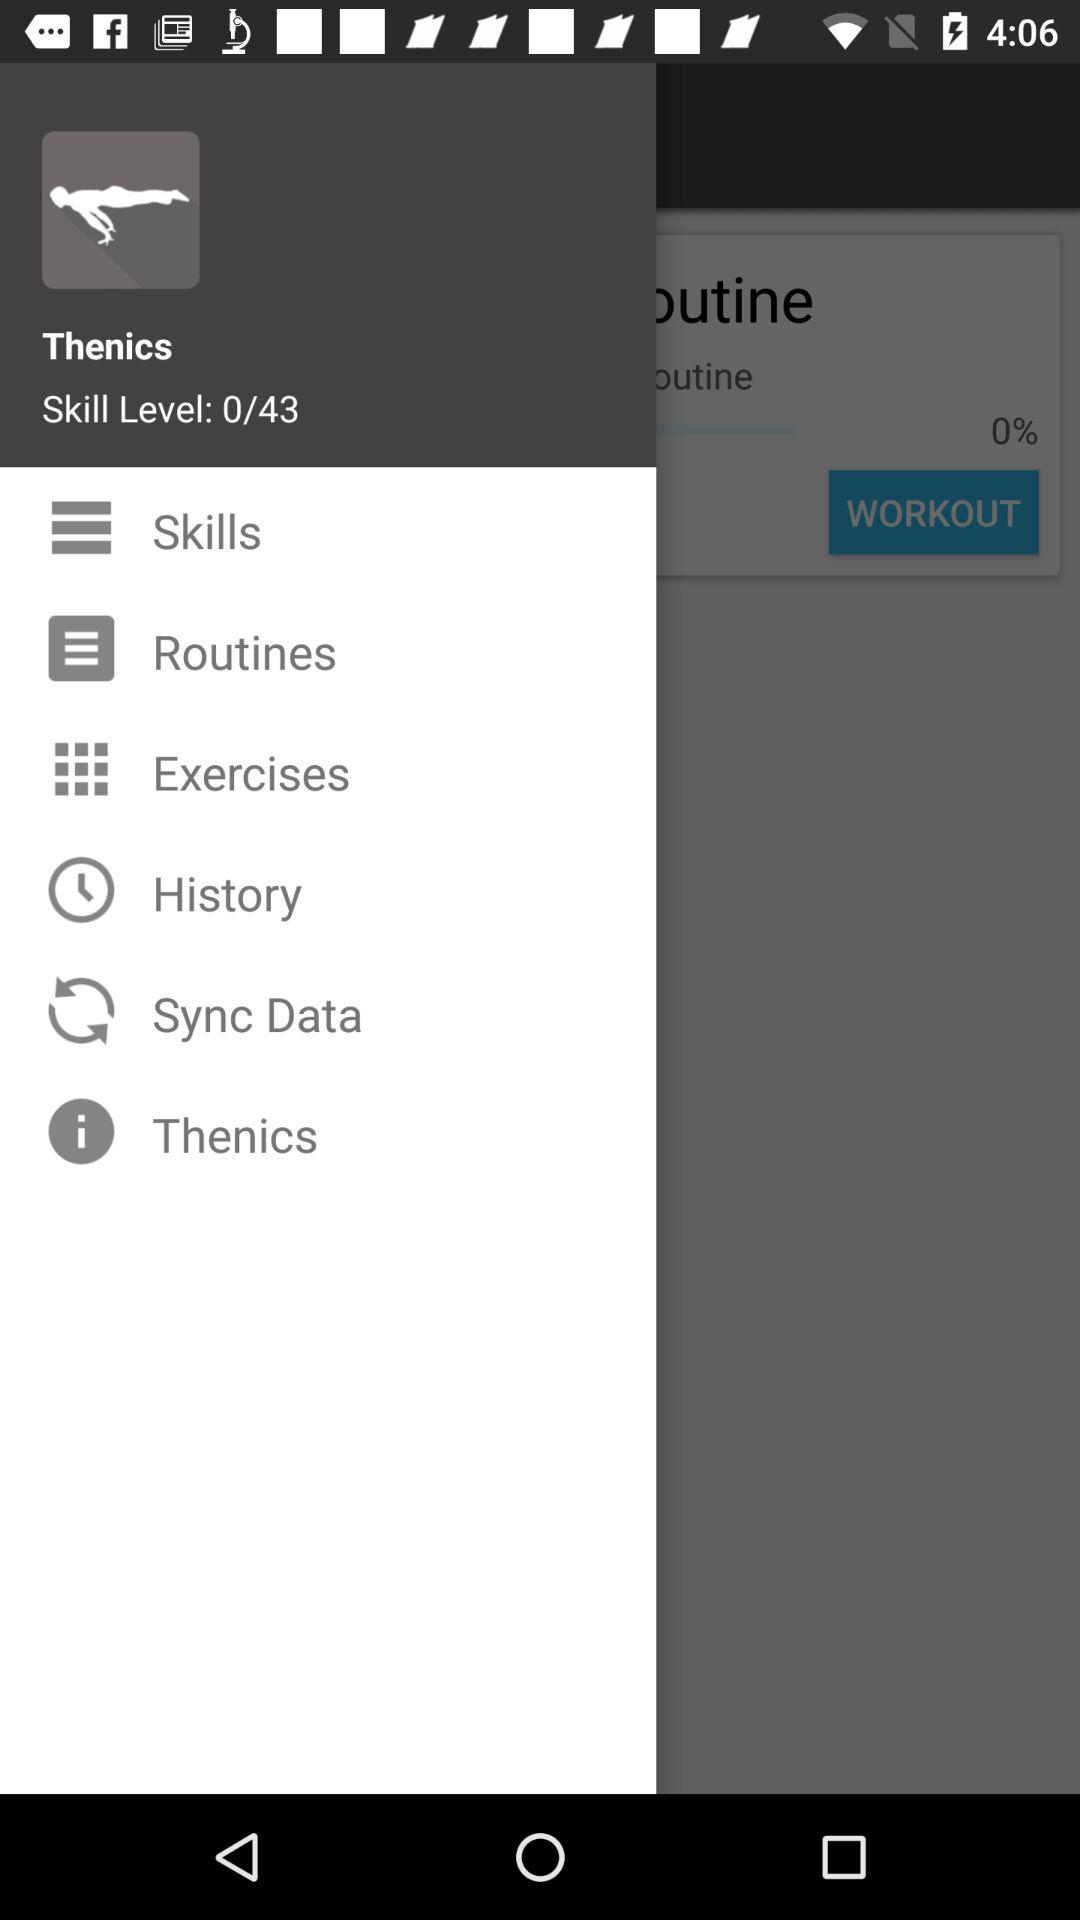What is the percentage of the skill level completed?
Answer the question using a single word or phrase. 0% 